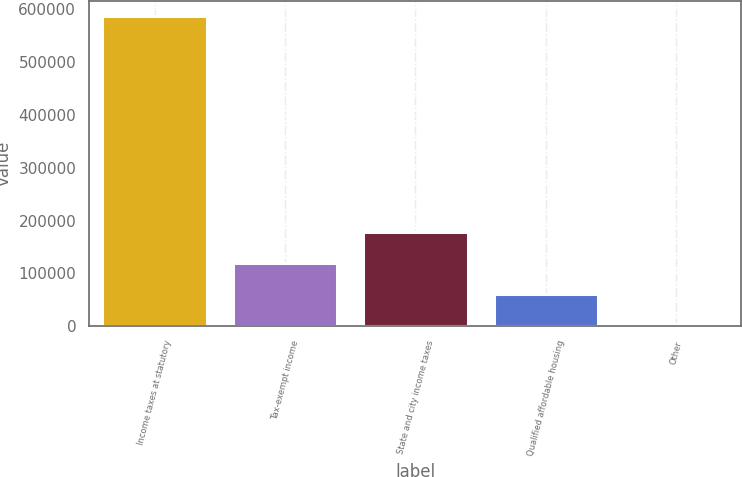Convert chart to OTSL. <chart><loc_0><loc_0><loc_500><loc_500><bar_chart><fcel>Income taxes at statutory<fcel>Tax-exempt income<fcel>State and city income taxes<fcel>Qualified affordable housing<fcel>Other<nl><fcel>586142<fcel>120193<fcel>178437<fcel>61949.6<fcel>3706<nl></chart> 